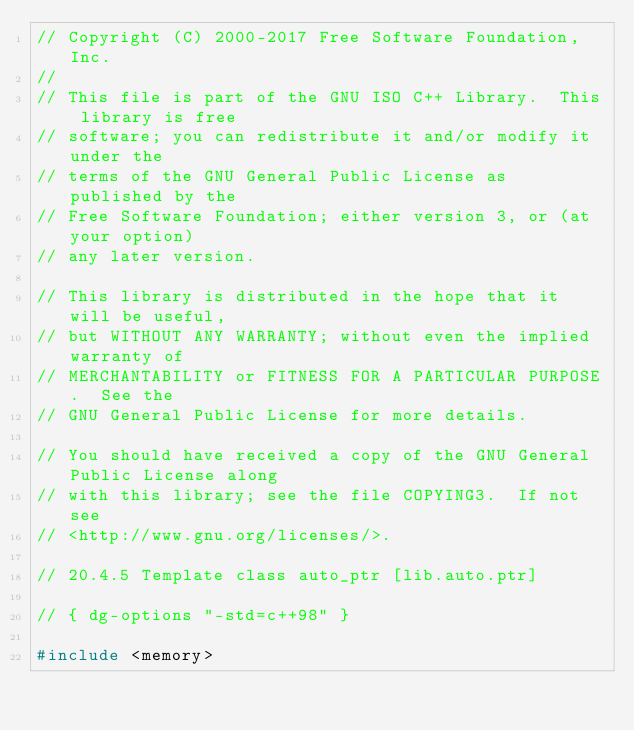Convert code to text. <code><loc_0><loc_0><loc_500><loc_500><_C++_>// Copyright (C) 2000-2017 Free Software Foundation, Inc.
//
// This file is part of the GNU ISO C++ Library.  This library is free
// software; you can redistribute it and/or modify it under the
// terms of the GNU General Public License as published by the
// Free Software Foundation; either version 3, or (at your option)
// any later version.

// This library is distributed in the hope that it will be useful,
// but WITHOUT ANY WARRANTY; without even the implied warranty of
// MERCHANTABILITY or FITNESS FOR A PARTICULAR PURPOSE.  See the
// GNU General Public License for more details.

// You should have received a copy of the GNU General Public License along
// with this library; see the file COPYING3.  If not see
// <http://www.gnu.org/licenses/>.

// 20.4.5 Template class auto_ptr [lib.auto.ptr]

// { dg-options "-std=c++98" }

#include <memory></code> 